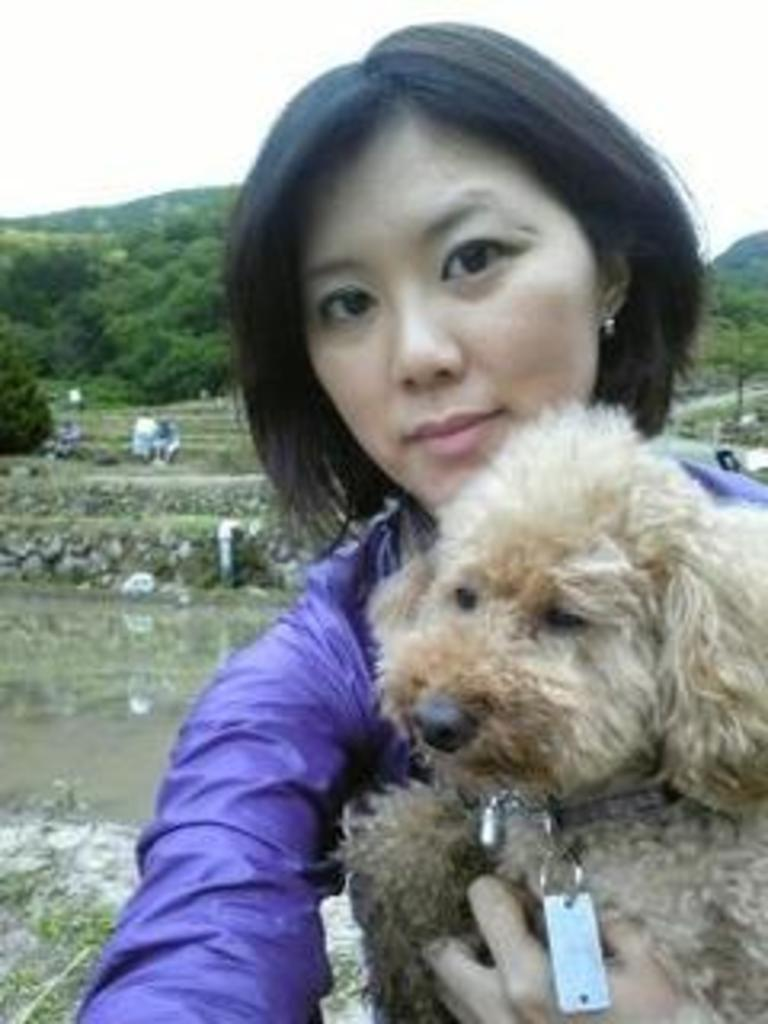Who is present in the image? There is a woman in the image. What is the woman holding? The woman is holding a dog. What can be seen in the background of the image? There is water, a tree, and the sky visible in the background. What type of sound can be heard coming from the police car in the image? There is no police car present in the image, so it's not possible to determine what, if any, sound might be heard. 